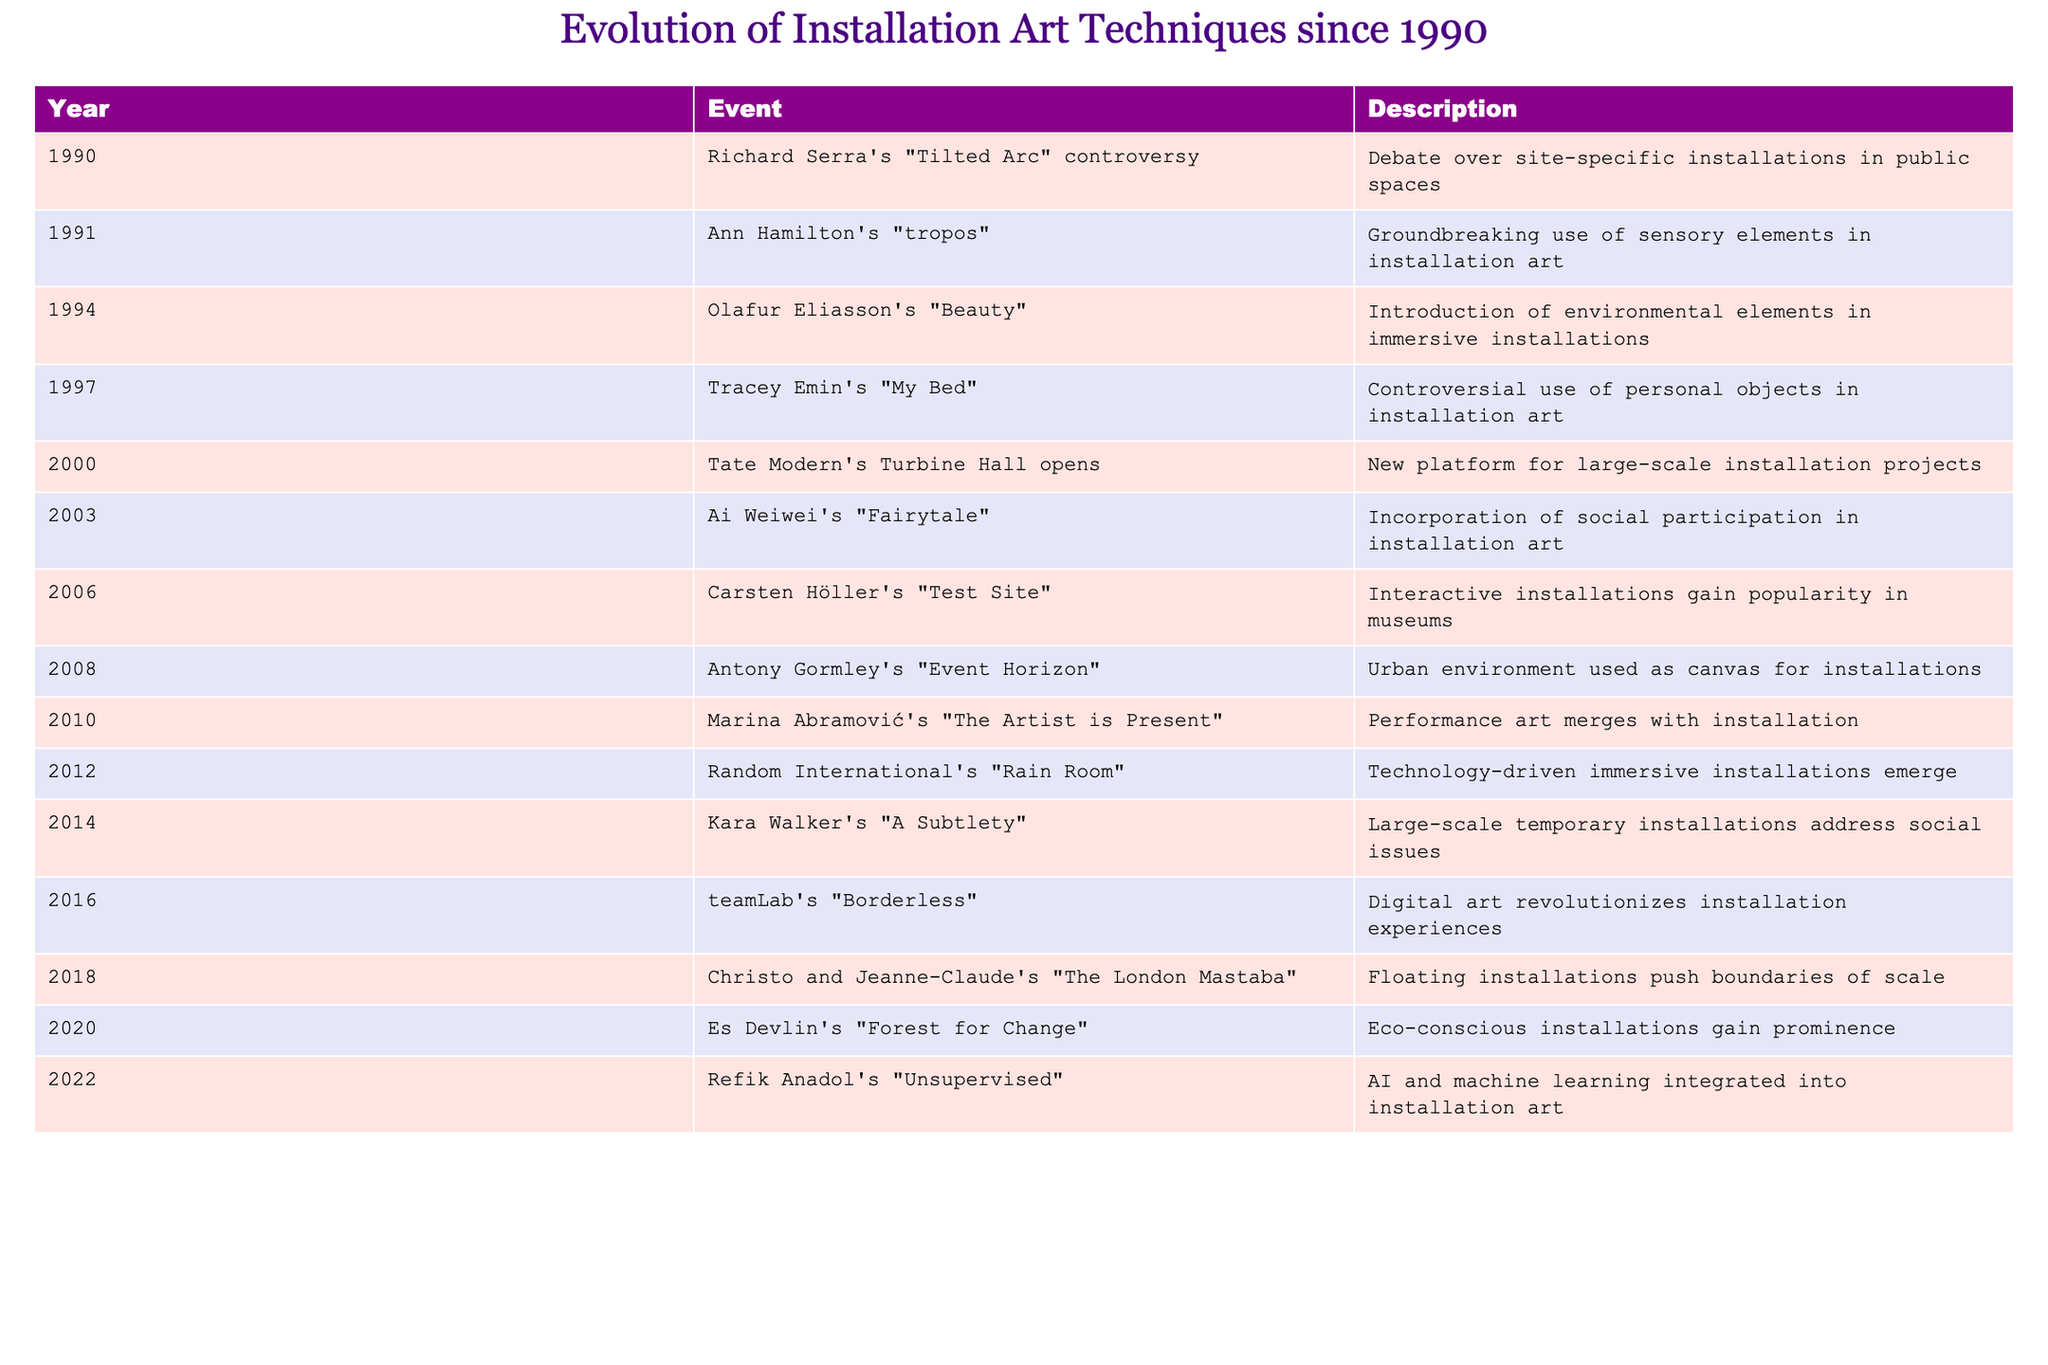What installation art piece in 1997 was controversial due to the use of personal objects? The table lists Tracey Emin's "My Bed" as a controversial installation in 1997, highlighting its focus on personal objects.
Answer: "My Bed" Which artist's work in 2003 incorporated social participation? According to the table, Ai Weiwei's "Fairytale" introduced social participation into installation art in 2003.
Answer: Ai Weiwei's "Fairytale" What is the total number of installation art events listed in the table from 1990 to 2022? The table contains 15 rows of events spanning from 1990 to 2022, indicating that there are a total of 15 installation art events listed.
Answer: 15 Is it true that the Tate Modern's Turbine Hall opened in the year 2000? The table confirms that the Tate Modern's Turbine Hall is listed as an event in the year 2000, making the statement true.
Answer: True What is the chronological order of the first three events listed in the table? By reviewing the table, the events are: 1990 (Tilted Arc controversy), 1991 (tropos), and 1994 (Beauty). This establishes their chronological order as mentioned.
Answer: 1990, 1991, 1994 How many installation art events occurred after 2010? Events after 2010 include "Rain Room" (2012), "A Subtlety" (2014), "Borderless" (2016), "The London Mastaba" (2018), "Forest for Change" (2020), and "Unsupervised" (2022), totaling 6 events.
Answer: 6 Which technique was emphasized in Marina Abramović's 2010 work? The table indicates that Abramović's "The Artist is Present" merges performance art with installation, emphasizing the technique of performance within installation art.
Answer: Merging performance art with installation What year marked the introduction of technology-driven immersive installations? As per the table, 2012 marked the introduction of technology-driven immersive installations with Random International's "Rain Room".
Answer: 2012 